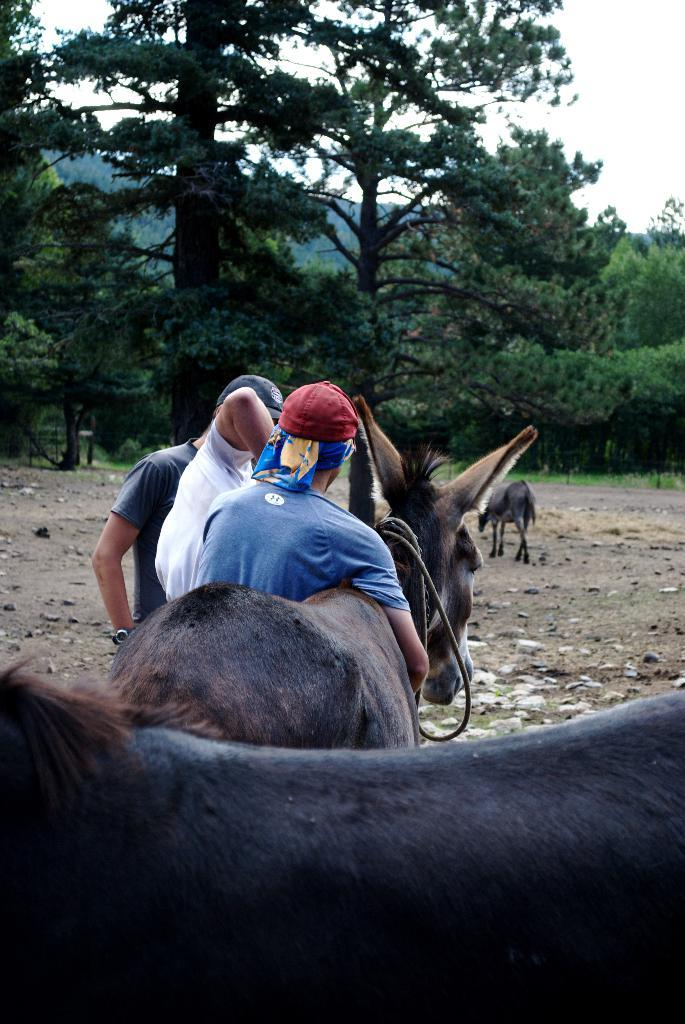What animals can be seen in the image? There are horses in the image. What are the two persons on the road doing? The question cannot be definitively answered from the provided facts. What can be seen in the background of the image? There are trees and the sky visible in the background of the image. What type of worm can be seen crawling on the chin of one of the horses in the image? There is no worm present in the image, and no horse's chin is visible. 